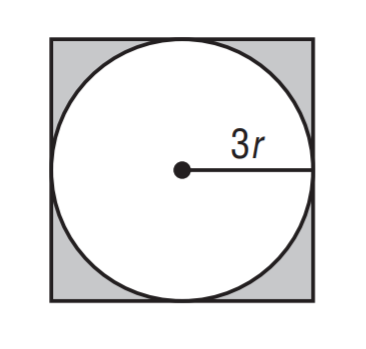Question: Find the ratio of the area of the circle to the area of the square.
Choices:
A. \frac { \pi } { 4 }
B. \frac { \pi } { 2 }
C. \frac { 3 \pi } { 4 }
D. \pi
Answer with the letter. Answer: A 